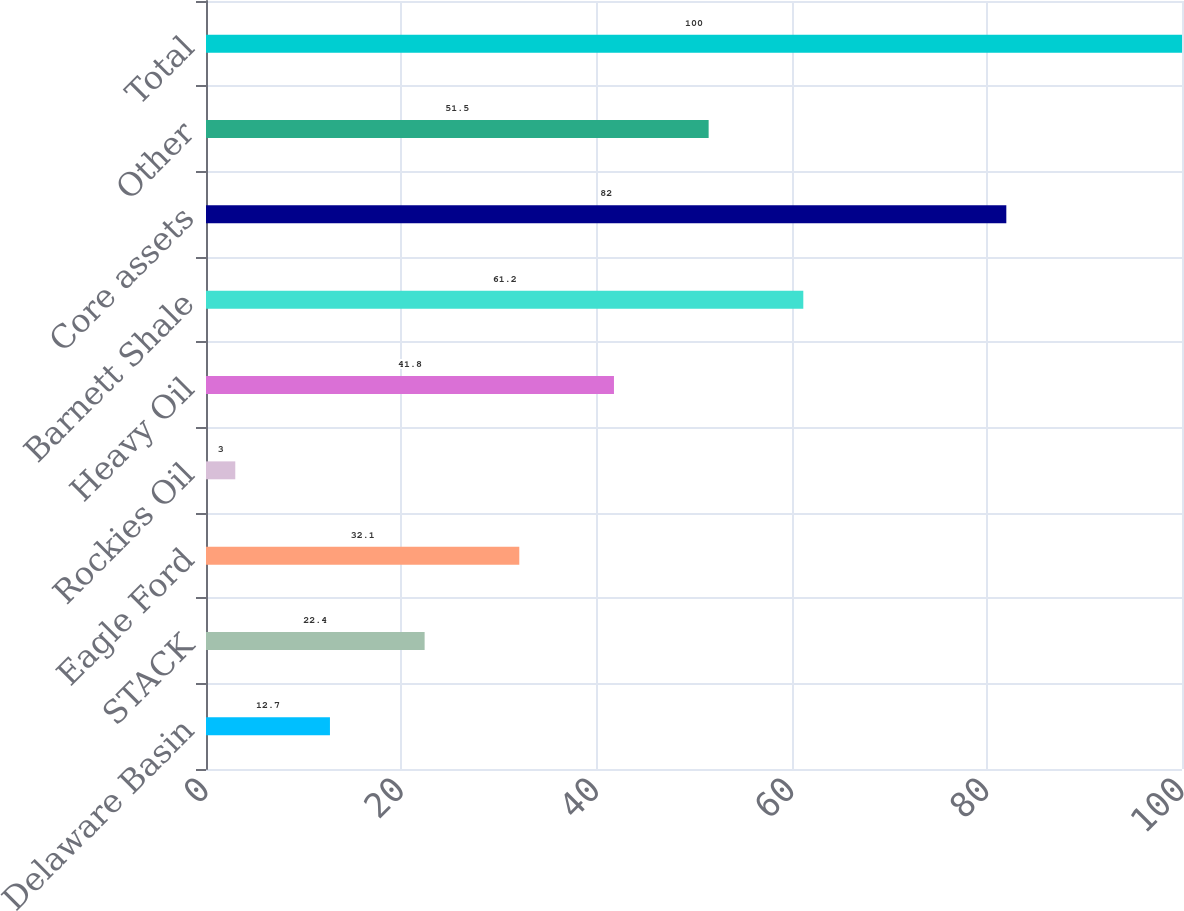Convert chart to OTSL. <chart><loc_0><loc_0><loc_500><loc_500><bar_chart><fcel>Delaware Basin<fcel>STACK<fcel>Eagle Ford<fcel>Rockies Oil<fcel>Heavy Oil<fcel>Barnett Shale<fcel>Core assets<fcel>Other<fcel>Total<nl><fcel>12.7<fcel>22.4<fcel>32.1<fcel>3<fcel>41.8<fcel>61.2<fcel>82<fcel>51.5<fcel>100<nl></chart> 